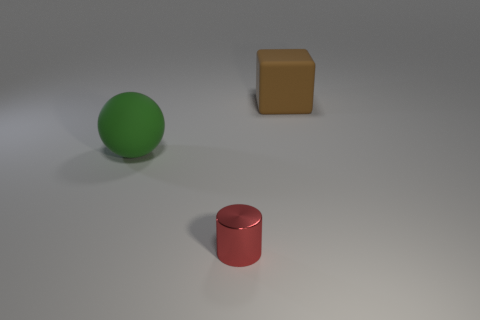Add 2 green shiny cylinders. How many objects exist? 5 Subtract all shiny objects. Subtract all tiny metallic cylinders. How many objects are left? 1 Add 3 brown rubber blocks. How many brown rubber blocks are left? 4 Add 1 gray rubber cylinders. How many gray rubber cylinders exist? 1 Subtract 0 green cubes. How many objects are left? 3 Subtract all balls. How many objects are left? 2 